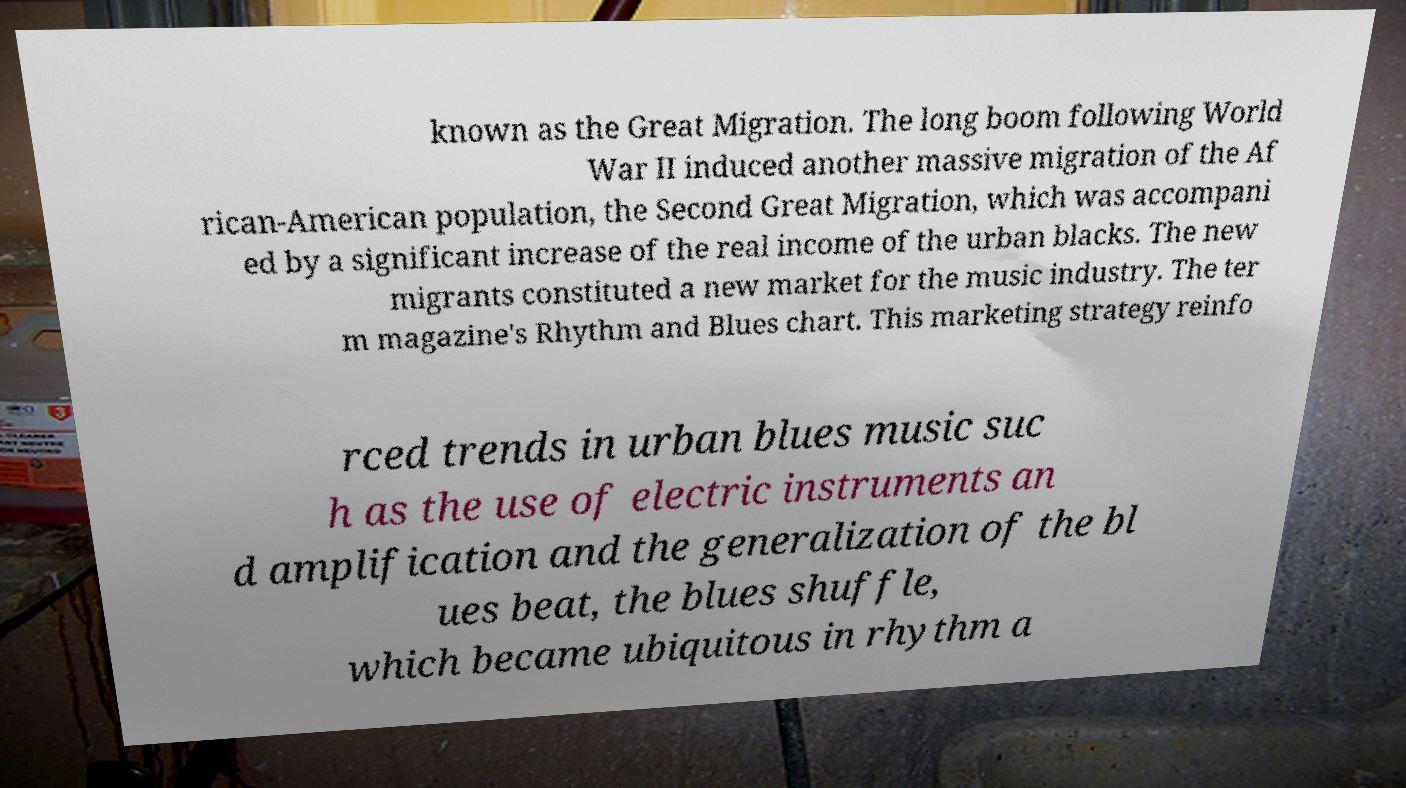For documentation purposes, I need the text within this image transcribed. Could you provide that? known as the Great Migration. The long boom following World War II induced another massive migration of the Af rican-American population, the Second Great Migration, which was accompani ed by a significant increase of the real income of the urban blacks. The new migrants constituted a new market for the music industry. The ter m magazine's Rhythm and Blues chart. This marketing strategy reinfo rced trends in urban blues music suc h as the use of electric instruments an d amplification and the generalization of the bl ues beat, the blues shuffle, which became ubiquitous in rhythm a 